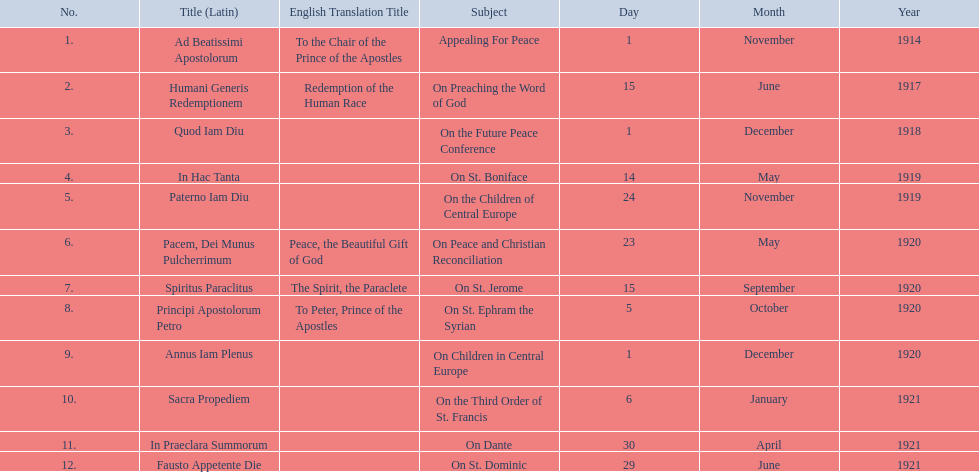What are all the subjects? Appealing For Peace, On Preaching the Word of God, On the Future Peace Conference, On St. Boniface, On the Children of Central Europe, On Peace and Christian Reconciliation, On St. Jerome, On St. Ephram the Syrian, On Children in Central Europe, On the Third Order of St. Francis, On Dante, On St. Dominic. Which occurred in 1920? On Peace and Christian Reconciliation, On St. Jerome, On St. Ephram the Syrian, On Children in Central Europe. Which occurred in may of that year? On Peace and Christian Reconciliation. 